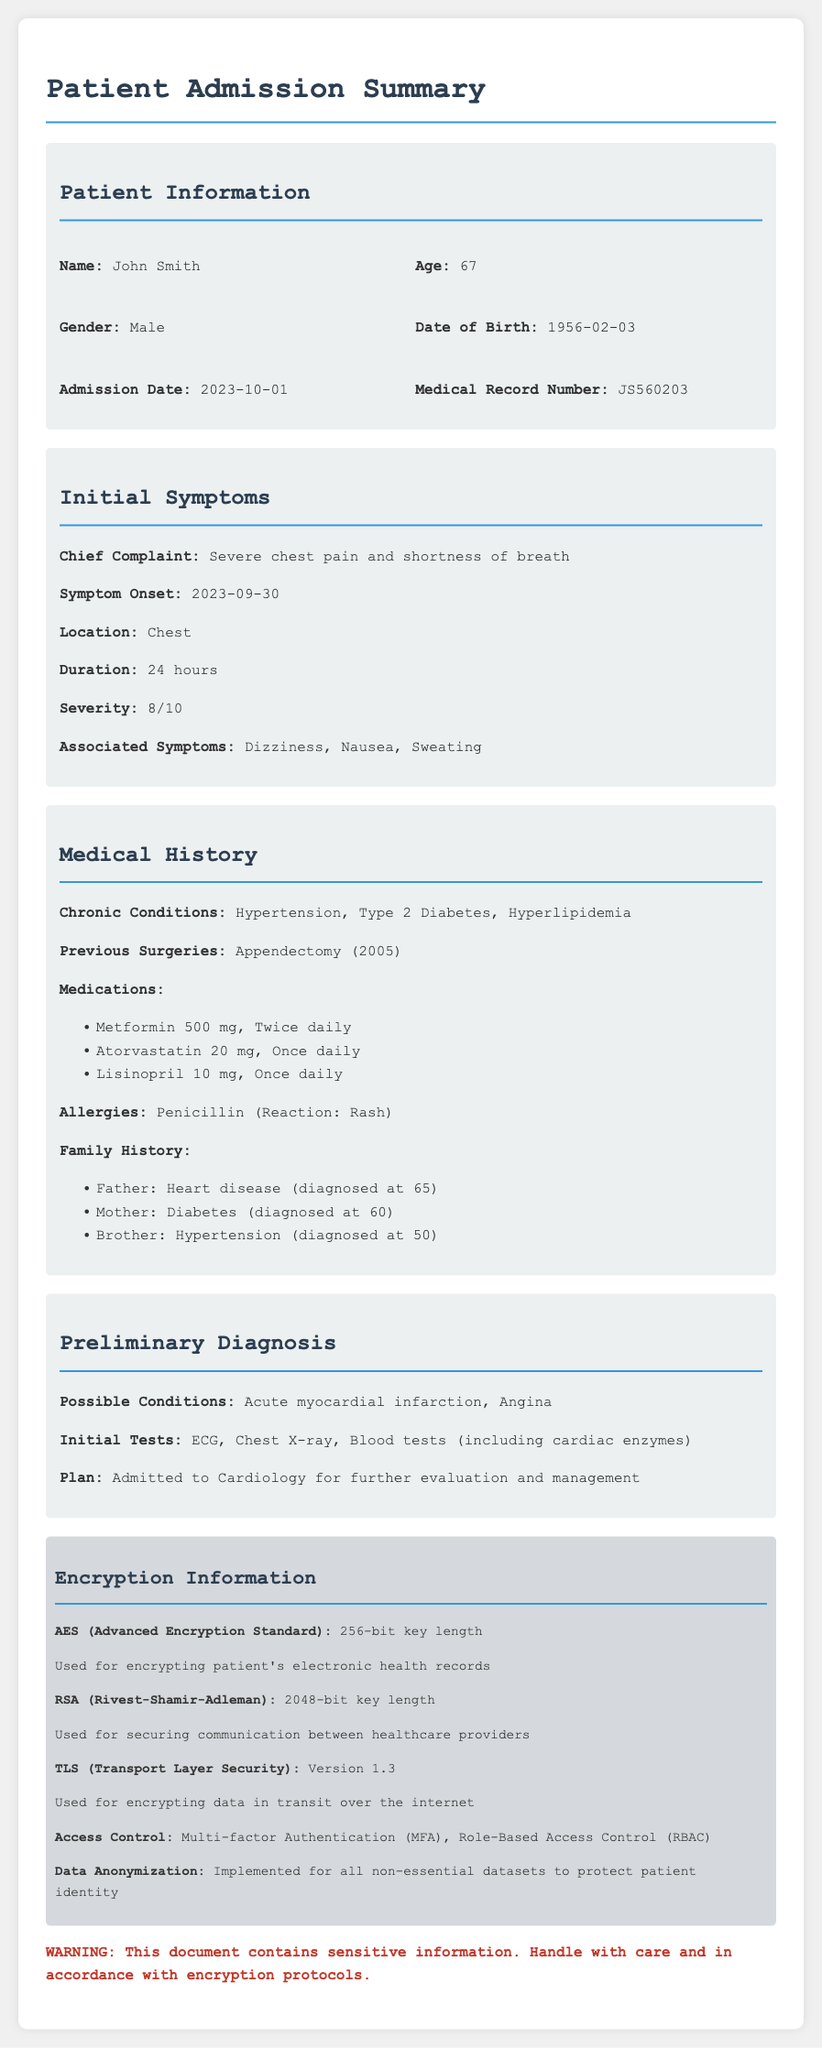What is the patient's name? The document provides the patient's name in the Patient Information section.
Answer: John Smith What was the chief complaint of the patient? The chief complaint is detailed in the Initial Symptoms section of the document.
Answer: Severe chest pain and shortness of breath When did the symptom onset occur? The symptom onset date is mentioned in the Initial Symptoms section.
Answer: 2023-09-30 What are the chronic conditions listed? The chronic conditions are described in the Medical History section of the document.
Answer: Hypertension, Type 2 Diabetes, Hyperlipidemia What is the possible condition indicated in the preliminary diagnosis? The possible conditions are mentioned in the Preliminary Diagnosis section.
Answer: Acute myocardial infarction, Angina Which encryption method is used for securing communication between healthcare providers? The encryption method for communication is specified in the Encryption Information section.
Answer: RSA (Rivest-Shamir-Adleman) What kind of access control is implemented? The document mentions the access control implemented in the Encryption Information section.
Answer: Multi-factor Authentication (MFA), Role-Based Access Control (RBAC) What is the severity rating of the patient's chest pain? The severity of the chest pain is given in the Initial Symptoms section.
Answer: 8/10 What year was the patient born? The year of birth is included in the Patient Information section.
Answer: 1956 